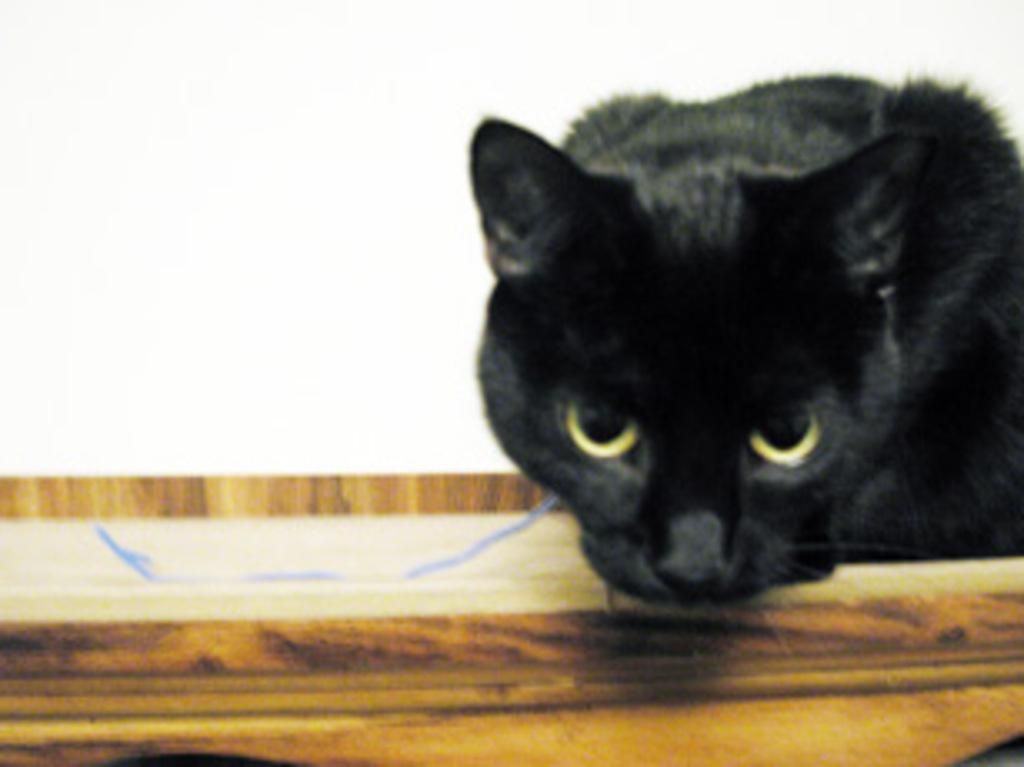How would you summarize this image in a sentence or two? In this picture we can see a black cat on a wooden object and in the background we can see white color. 